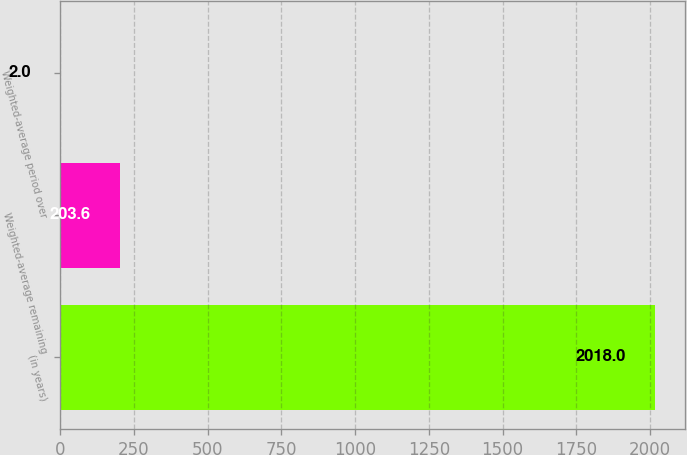<chart> <loc_0><loc_0><loc_500><loc_500><bar_chart><fcel>(in years)<fcel>Weighted-average remaining<fcel>Weighted-average period over<nl><fcel>2018<fcel>203.6<fcel>2<nl></chart> 